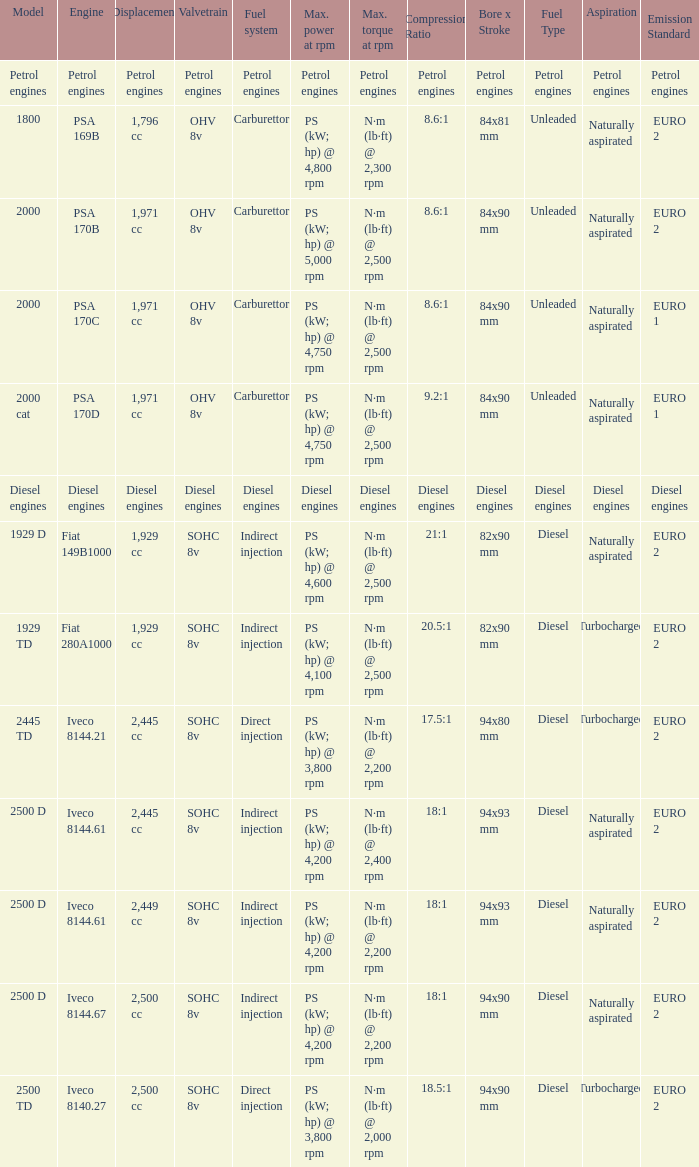Can you parse all the data within this table? {'header': ['Model', 'Engine', 'Displacement', 'Valvetrain', 'Fuel system', 'Max. power at rpm', 'Max. torque at rpm', 'Compression Ratio', 'Bore x Stroke', 'Fuel Type', 'Aspiration', 'Emission Standard'], 'rows': [['Petrol engines', 'Petrol engines', 'Petrol engines', 'Petrol engines', 'Petrol engines', 'Petrol engines', 'Petrol engines', 'Petrol engines', 'Petrol engines', 'Petrol engines', 'Petrol engines', 'Petrol engines'], ['1800', 'PSA 169B', '1,796 cc', 'OHV 8v', 'Carburettor', 'PS (kW; hp) @ 4,800 rpm', 'N·m (lb·ft) @ 2,300 rpm', '8.6:1', '84x81 mm', 'Unleaded', 'Naturally aspirated', 'EURO 2'], ['2000', 'PSA 170B', '1,971 cc', 'OHV 8v', 'Carburettor', 'PS (kW; hp) @ 5,000 rpm', 'N·m (lb·ft) @ 2,500 rpm', '8.6:1', '84x90 mm', 'Unleaded', 'Naturally aspirated', 'EURO 2'], ['2000', 'PSA 170C', '1,971 cc', 'OHV 8v', 'Carburettor', 'PS (kW; hp) @ 4,750 rpm', 'N·m (lb·ft) @ 2,500 rpm', '8.6:1', '84x90 mm', 'Unleaded', 'Naturally aspirated', 'EURO 1'], ['2000 cat', 'PSA 170D', '1,971 cc', 'OHV 8v', 'Carburettor', 'PS (kW; hp) @ 4,750 rpm', 'N·m (lb·ft) @ 2,500 rpm', '9.2:1', '84x90 mm', 'Unleaded', 'Naturally aspirated', 'EURO 1'], ['Diesel engines', 'Diesel engines', 'Diesel engines', 'Diesel engines', 'Diesel engines', 'Diesel engines', 'Diesel engines', 'Diesel engines', 'Diesel engines', 'Diesel engines', 'Diesel engines', 'Diesel engines'], ['1929 D', 'Fiat 149B1000', '1,929 cc', 'SOHC 8v', 'Indirect injection', 'PS (kW; hp) @ 4,600 rpm', 'N·m (lb·ft) @ 2,500 rpm', '21:1', '82x90 mm', 'Diesel', 'Naturally aspirated', 'EURO 2'], ['1929 TD', 'Fiat 280A1000', '1,929 cc', 'SOHC 8v', 'Indirect injection', 'PS (kW; hp) @ 4,100 rpm', 'N·m (lb·ft) @ 2,500 rpm', '20.5:1', '82x90 mm', 'Diesel', 'Turbocharged', 'EURO 2'], ['2445 TD', 'Iveco 8144.21', '2,445 cc', 'SOHC 8v', 'Direct injection', 'PS (kW; hp) @ 3,800 rpm', 'N·m (lb·ft) @ 2,200 rpm', '17.5:1', '94x80 mm', 'Diesel', 'Turbocharged', 'EURO 2'], ['2500 D', 'Iveco 8144.61', '2,445 cc', 'SOHC 8v', 'Indirect injection', 'PS (kW; hp) @ 4,200 rpm', 'N·m (lb·ft) @ 2,400 rpm', '18:1', '94x93 mm', 'Diesel', 'Naturally aspirated', 'EURO 2'], ['2500 D', 'Iveco 8144.61', '2,449 cc', 'SOHC 8v', 'Indirect injection', 'PS (kW; hp) @ 4,200 rpm', 'N·m (lb·ft) @ 2,200 rpm', '18:1', '94x93 mm', 'Diesel', 'Naturally aspirated', 'EURO 2'], ['2500 D', 'Iveco 8144.67', '2,500 cc', 'SOHC 8v', 'Indirect injection', 'PS (kW; hp) @ 4,200 rpm', 'N·m (lb·ft) @ 2,200 rpm', '18:1', '94x90 mm', 'Diesel', 'Naturally aspirated', 'EURO 2'], ['2500 TD', 'Iveco 8140.27', '2,500 cc', 'SOHC 8v', 'Direct injection', 'PS (kW; hp) @ 3,800 rpm', 'N·m (lb·ft) @ 2,000 rpm', '18.5:1', '94x90 mm', 'Diesel', 'Turbocharged', 'EURO 2']]} What is the maximum torque that has 2,445 CC Displacement, and an Iveco 8144.61 engine? N·m (lb·ft) @ 2,400 rpm. 